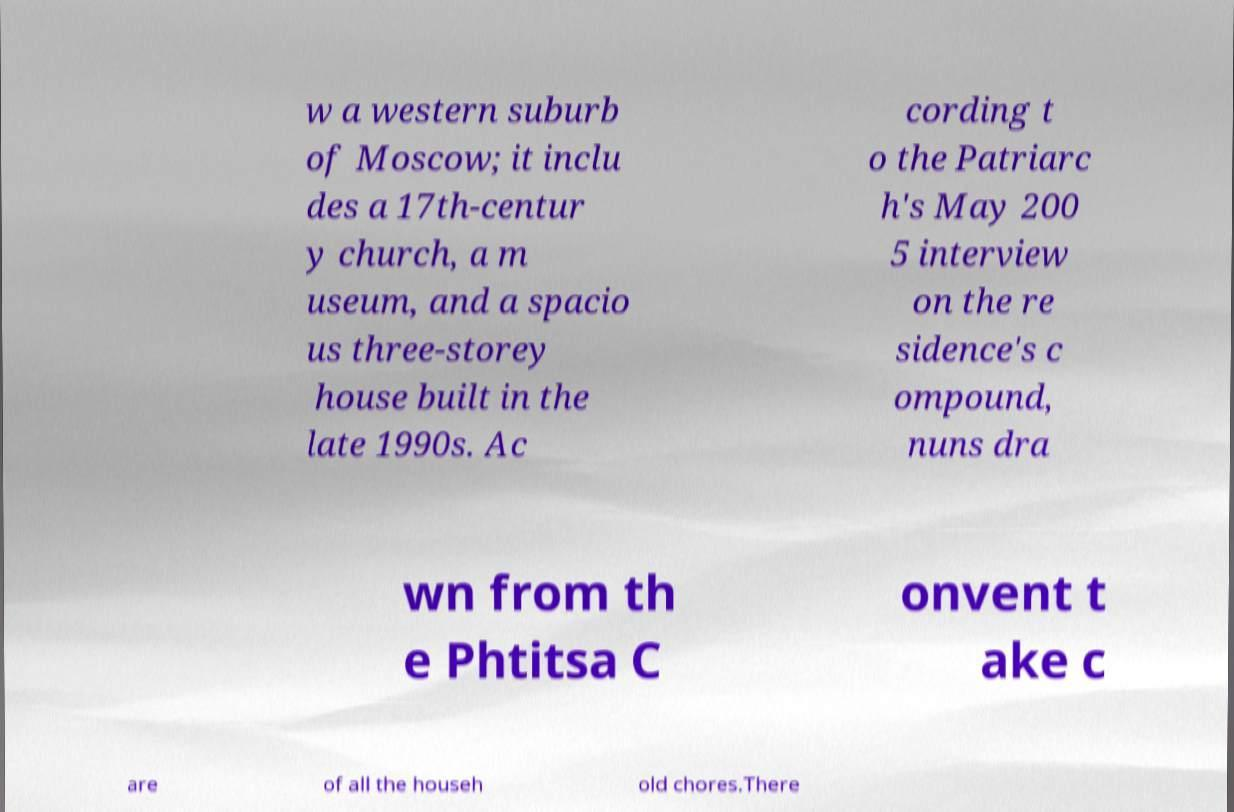Could you extract and type out the text from this image? w a western suburb of Moscow; it inclu des a 17th-centur y church, a m useum, and a spacio us three-storey house built in the late 1990s. Ac cording t o the Patriarc h's May 200 5 interview on the re sidence's c ompound, nuns dra wn from th e Phtitsa C onvent t ake c are of all the househ old chores.There 